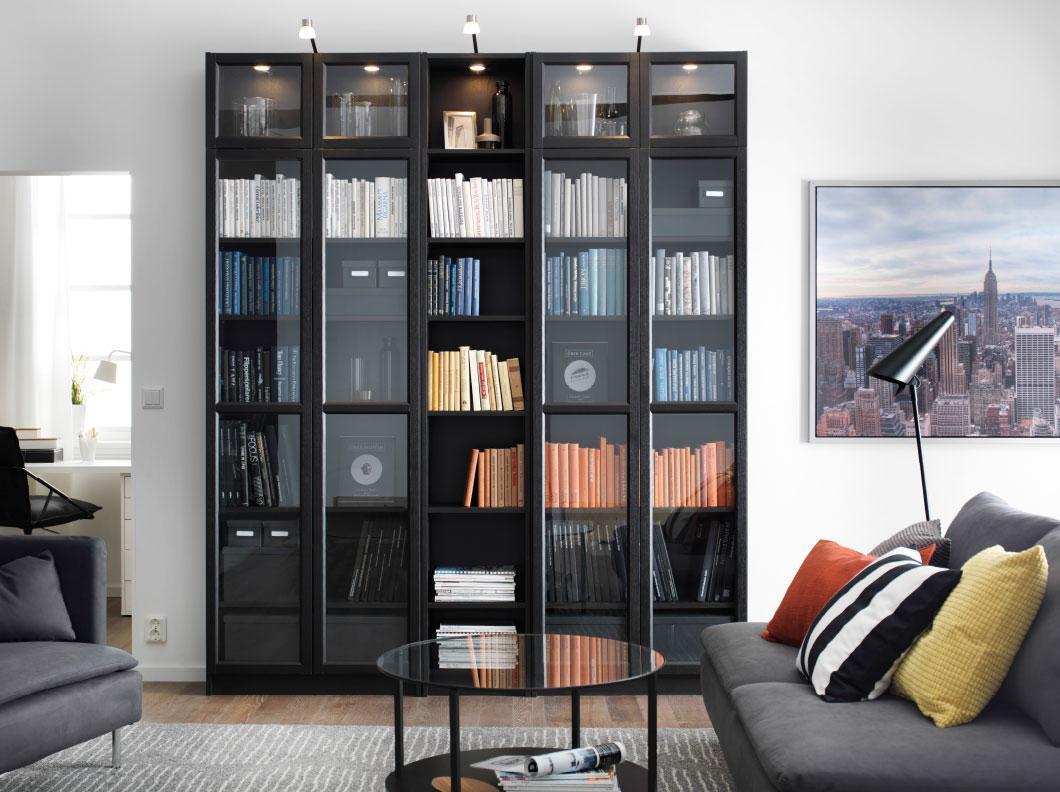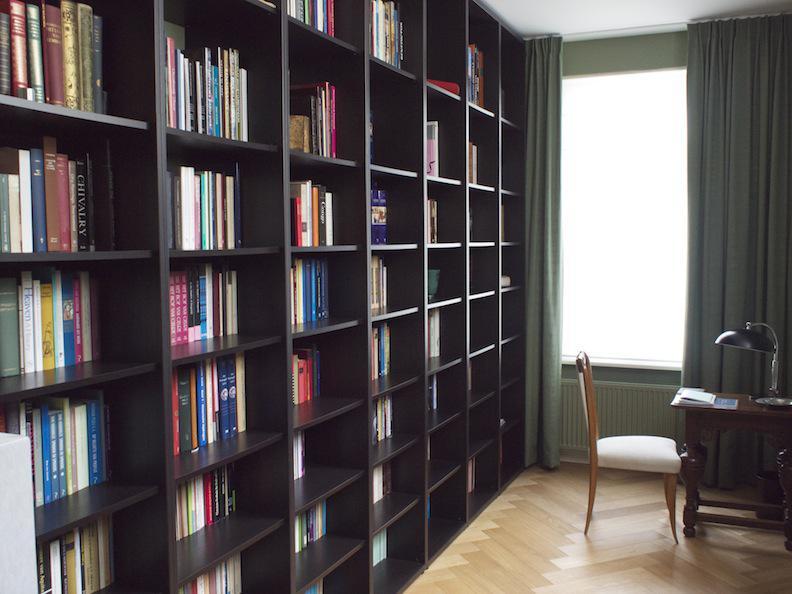The first image is the image on the left, the second image is the image on the right. Evaluate the accuracy of this statement regarding the images: "One image shows a green plant in a white vase standing on the floor to the left of an upright set of shelves with closed, glass-front double doors.". Is it true? Answer yes or no. No. The first image is the image on the left, the second image is the image on the right. Evaluate the accuracy of this statement regarding the images: "A single white lamp hangs down from the ceiling in one of the images.". Is it true? Answer yes or no. No. 